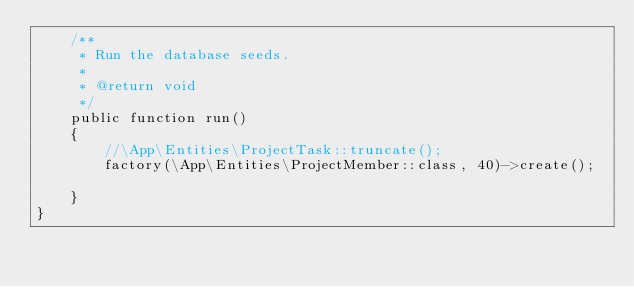Convert code to text. <code><loc_0><loc_0><loc_500><loc_500><_PHP_>    /**
     * Run the database seeds.
     *
     * @return void
     */
    public function run()
    {
        //\App\Entities\ProjectTask::truncate();
        factory(\App\Entities\ProjectMember::class, 40)->create();
        
    }
}
</code> 